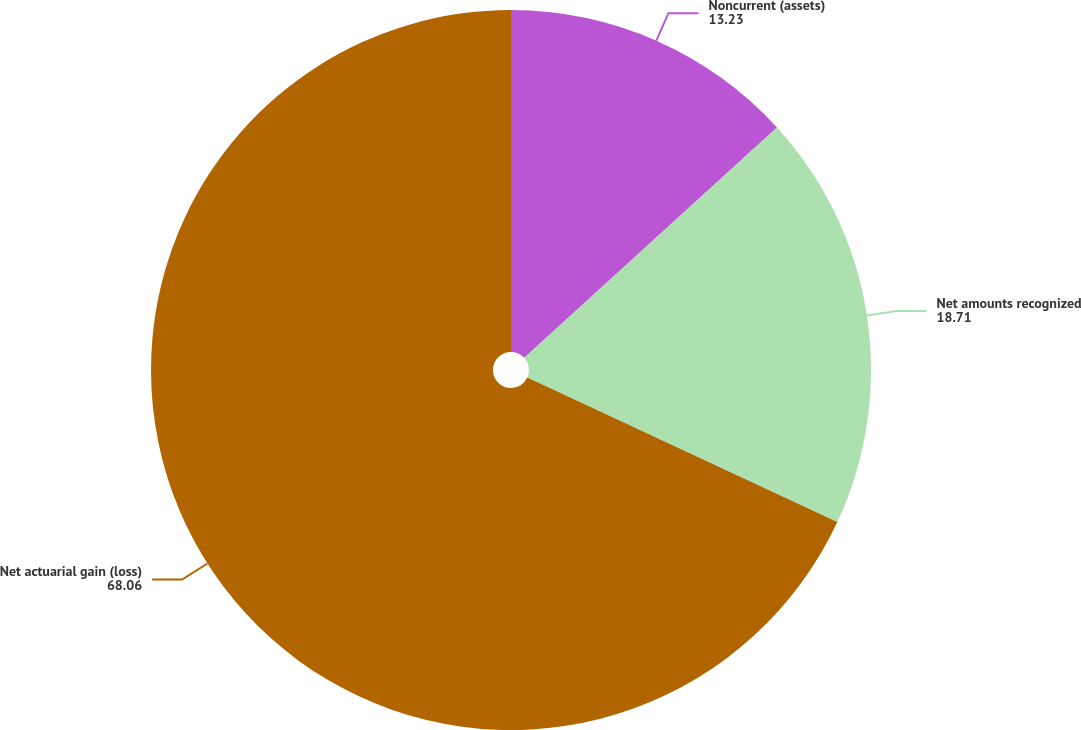<chart> <loc_0><loc_0><loc_500><loc_500><pie_chart><fcel>Noncurrent (assets)<fcel>Net amounts recognized<fcel>Net actuarial gain (loss)<nl><fcel>13.23%<fcel>18.71%<fcel>68.06%<nl></chart> 